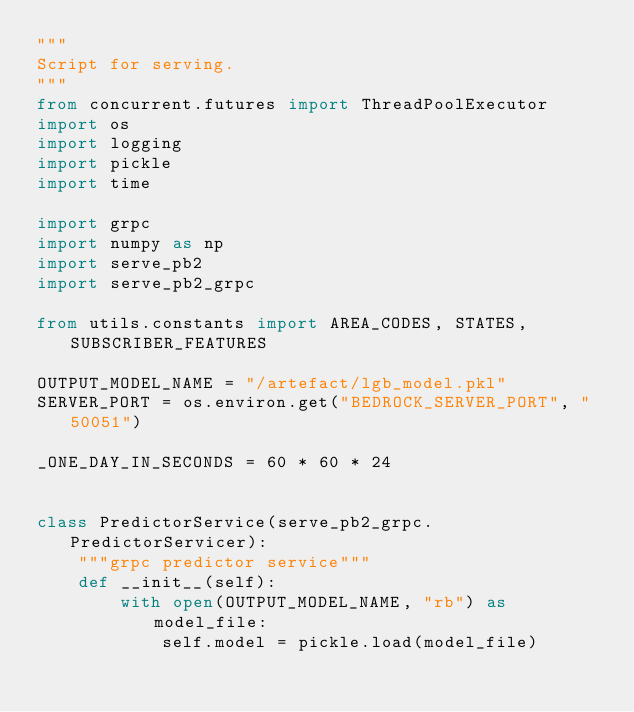<code> <loc_0><loc_0><loc_500><loc_500><_Python_>"""
Script for serving.
"""
from concurrent.futures import ThreadPoolExecutor
import os
import logging
import pickle
import time

import grpc
import numpy as np
import serve_pb2
import serve_pb2_grpc

from utils.constants import AREA_CODES, STATES, SUBSCRIBER_FEATURES

OUTPUT_MODEL_NAME = "/artefact/lgb_model.pkl"
SERVER_PORT = os.environ.get("BEDROCK_SERVER_PORT", "50051")

_ONE_DAY_IN_SECONDS = 60 * 60 * 24


class PredictorService(serve_pb2_grpc.PredictorServicer):
    """grpc predictor service"""
    def __init__(self):
        with open(OUTPUT_MODEL_NAME, "rb") as model_file:
            self.model = pickle.load(model_file)
</code> 